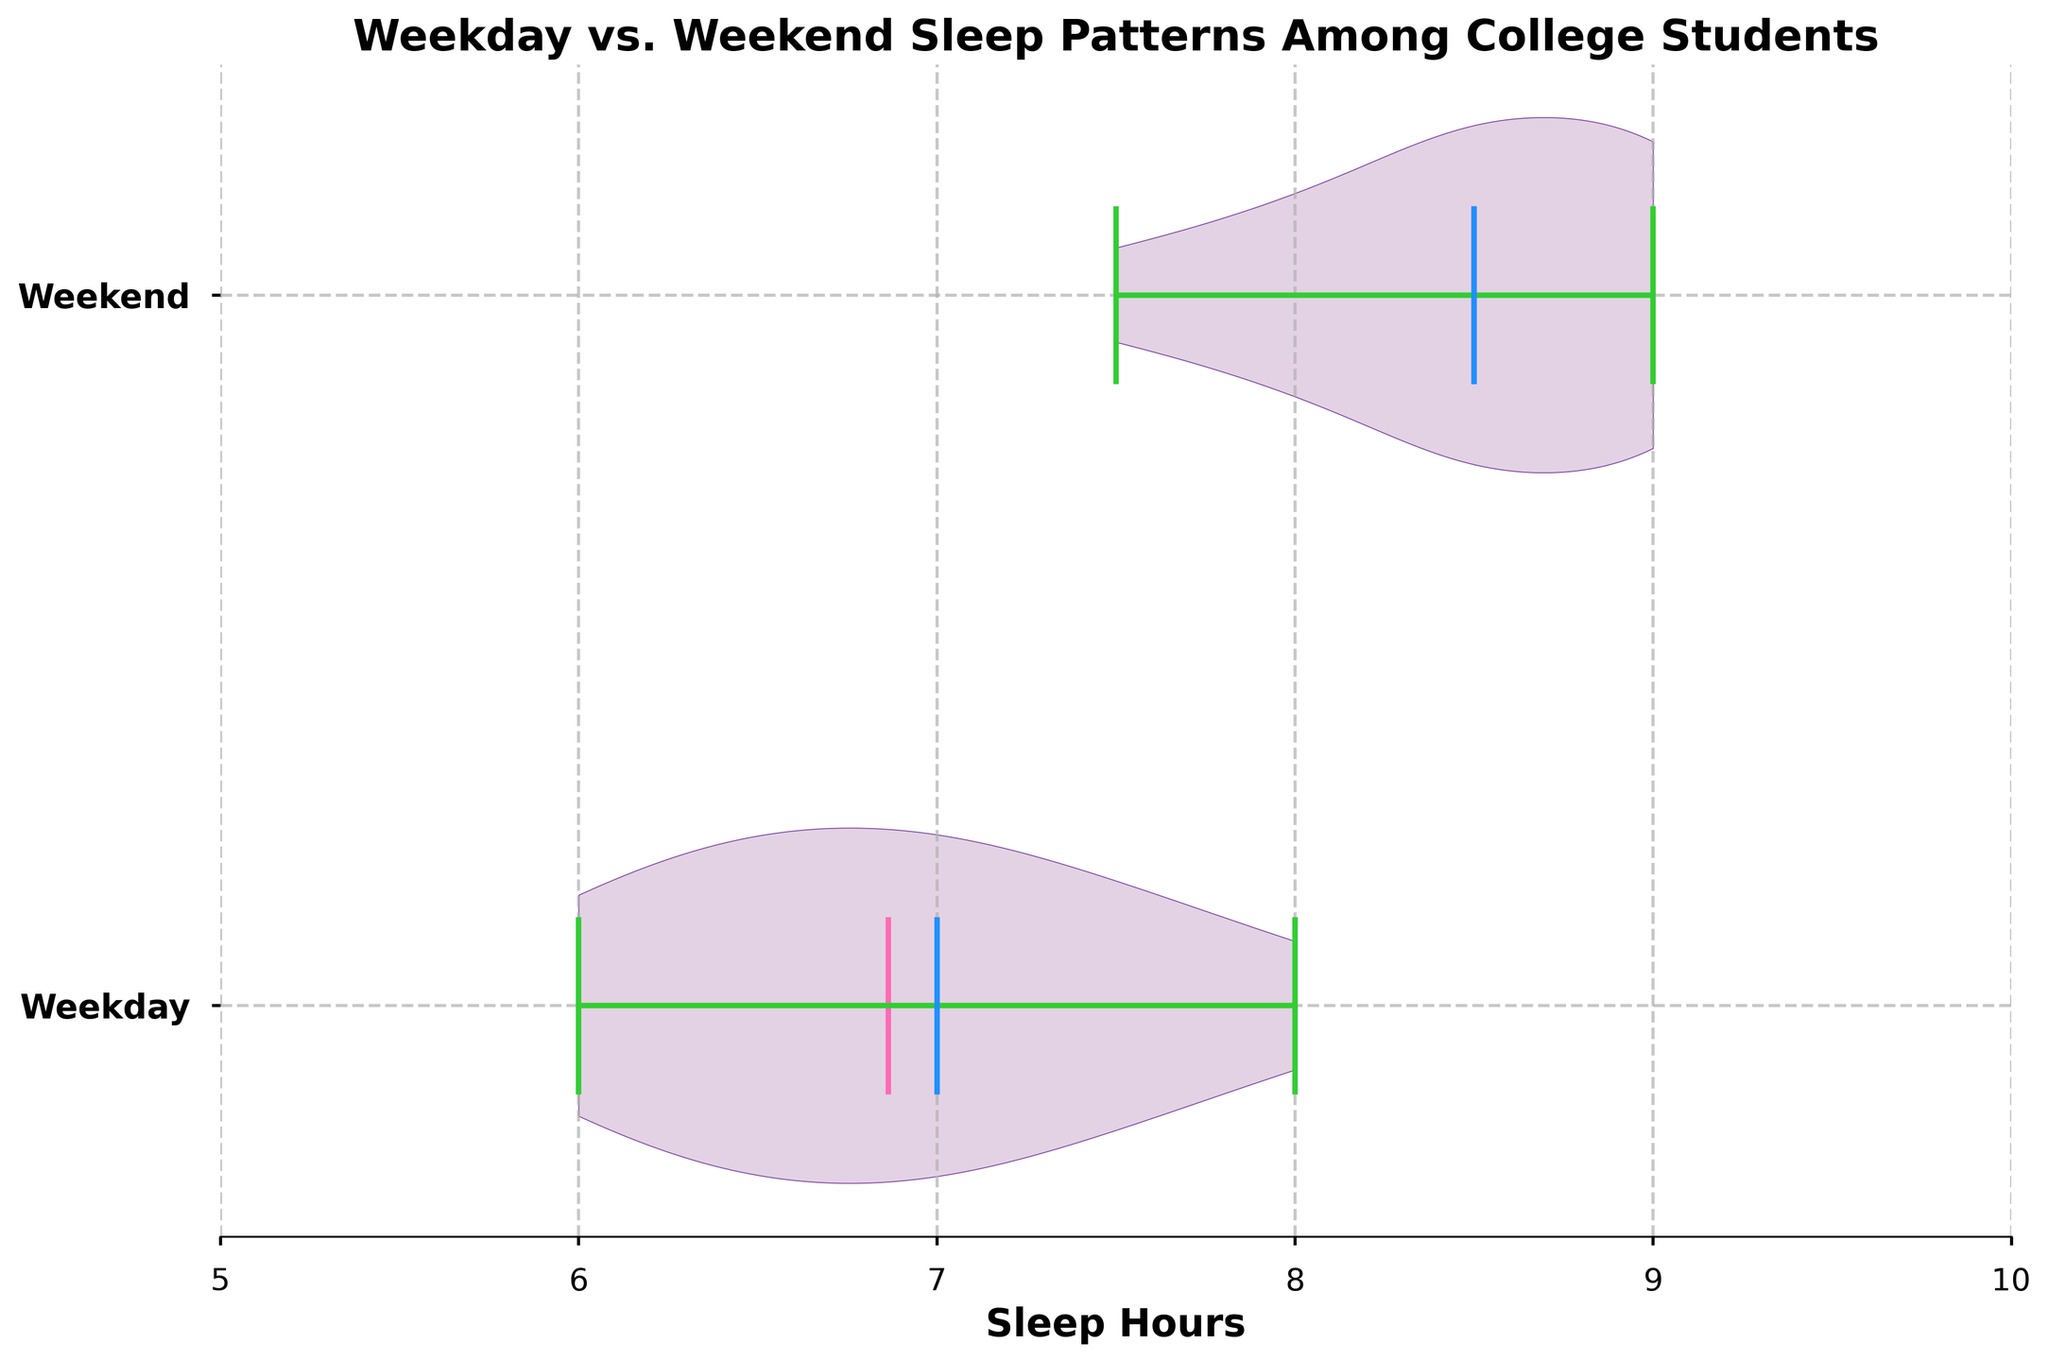What is the title of the chart? The chart's title is displayed at the top center of the figure and identifies the topic of the graph.
Answer: Weekday vs. Weekend Sleep Patterns Among College Students How many categories are there in the y-axis? The y-axis has two categories, as shown by the labels on the y-axis.
Answer: 2 What is the range of sleep hours shown on the x-axis? The x-axis has sleep hours ranging from 5 to 10, as indicated by the x-axis labels.
Answer: 5 to 10 Which day type shows a higher median sleep hours? The day type with a higher median value is indicated by a blue line (the median). By observing the blue lines, the weekend data shows a higher median value.
Answer: Weekend Does the violin plot show more variation in sleep hours for Weekdays or Weekends? The width of each violin plot corresponds to the distribution and variation. The wider the plot, the more variation. The weekend plot is clearly wider, indicating more variation.
Answer: Weekend Which color represents the mean sleep hours? The mean sleep hours are represented by a magenta (pink) line in the violin plots.
Answer: Magenta (pink) What is the approximate mean sleep hours for Weekends? The magenta line inside the weekend plot indicates the mean sleep hours, which appear to be around 8.5 hours.
Answer: 8.5 By how many hours does the maximum sleep hour on Weekend exceed that on Weekday? The green lines indicate maxima. On weekends, the maximum is around 9 hours, while on weekdays, it’s around 8 hours. The difference is 1 hour.
Answer: 1 Does the chart show whether any students sleep less than 6 hours on Weekdays? The minimum values of the weekday violin plot reach 6 and above, so no students sleep less than 6 hours on Weekdays.
Answer: No 